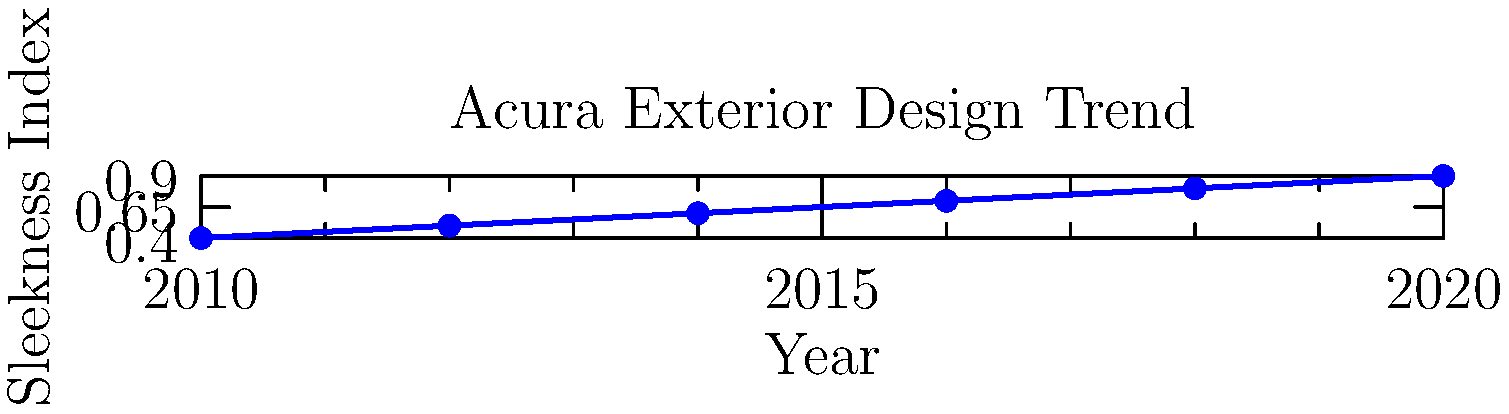Based on the graph showing the evolution of Acura's exterior design sleekness over time, what machine learning technique would be most appropriate for predicting the sleekness index for future years? To determine the most appropriate machine learning technique for predicting the sleekness index for future years, we need to analyze the given data and its characteristics:

1. The data shows a clear upward trend over time, suggesting a linear relationship between the year and the sleekness index.

2. The relationship appears to be monotonic and relatively smooth, without significant fluctuations or complex patterns.

3. We have a single input variable (year) and a single output variable (sleekness index).

4. The dataset is relatively small, with only six data points.

Given these observations, the most appropriate machine learning technique would be linear regression. Here's why:

1. Linear regression is well-suited for problems where there's a linear relationship between the input and output variables.

2. It works well with small datasets and doesn't require a large amount of training data.

3. Linear regression can easily handle single input and output variables.

4. It provides interpretable results, allowing us to understand the rate of change in sleekness over time.

5. Linear regression can be used for extrapolation, which is necessary for predicting future sleekness indices.

Other techniques like polynomial regression or more complex models (e.g., neural networks) would likely overfit this small dataset and may not generalize well for future predictions.
Answer: Linear regression 